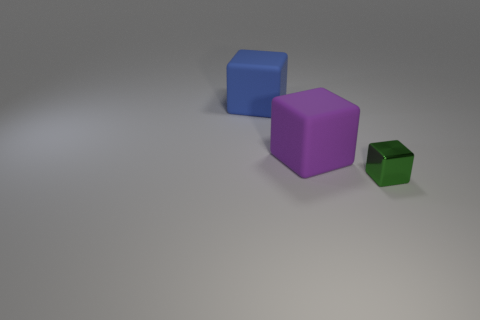Is there any other thing that is the same material as the small block?
Your answer should be very brief. No. The small object that is the same shape as the big purple thing is what color?
Offer a terse response. Green. How many other things are there of the same color as the small shiny object?
Your answer should be compact. 0. There is a rubber object on the right side of the large blue rubber block; does it have the same shape as the large blue thing that is on the left side of the purple matte block?
Give a very brief answer. Yes. What number of blocks are either big objects or green things?
Offer a very short reply. 3. Are there fewer big blue blocks that are right of the purple rubber cube than large purple matte objects?
Your answer should be compact. Yes. How many other things are there of the same material as the purple object?
Give a very brief answer. 1. Do the purple block and the shiny cube have the same size?
Your answer should be compact. No. How many objects are either blocks that are behind the shiny block or metal cubes?
Offer a very short reply. 3. The block that is right of the rubber block that is right of the large blue matte object is made of what material?
Your answer should be very brief. Metal. 